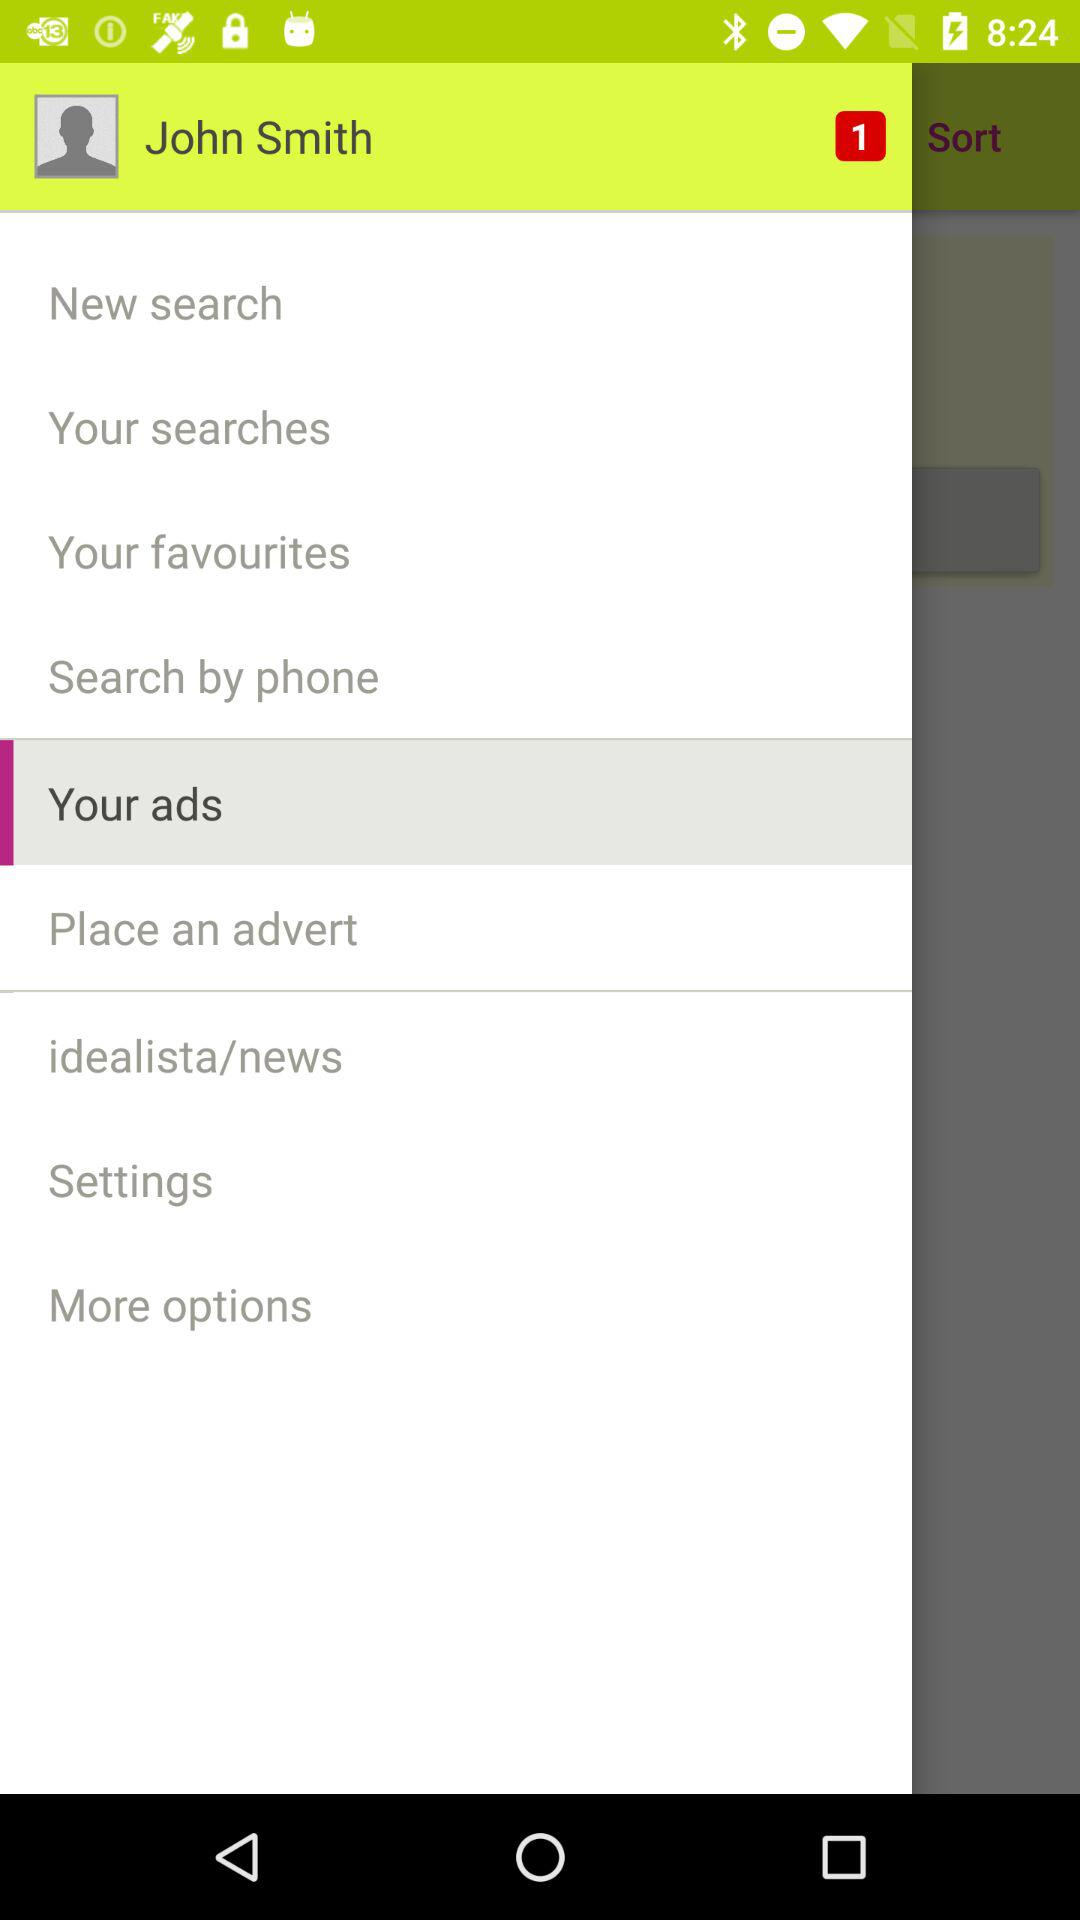What option has been selected? The selected option is "Your ads". 